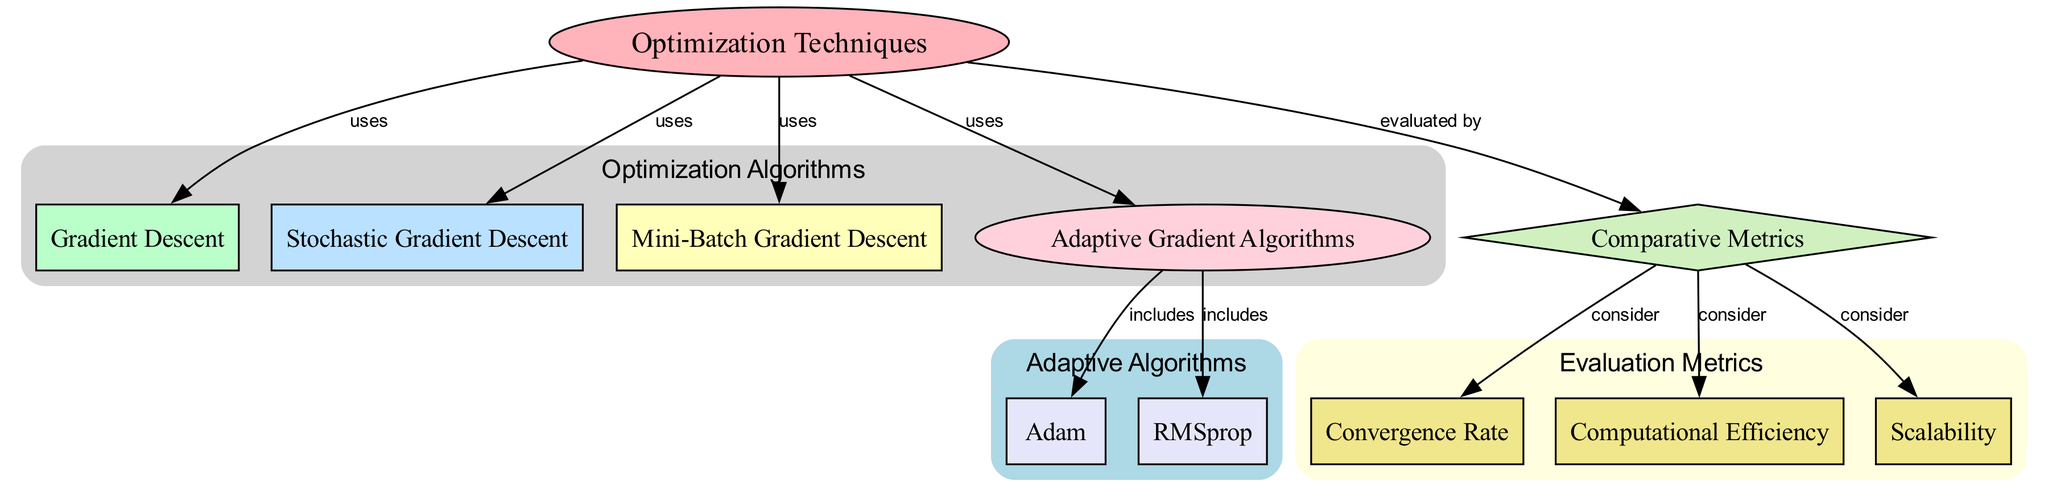What are the primary optimization techniques shown in the diagram? The diagram lists four primary optimization techniques: Gradient Descent, Stochastic Gradient Descent, Mini-Batch Gradient Descent, and Adaptive Gradient Algorithms. Each technique is represented as a node connected to the main node labeled "Optimization Techniques."
Answer: Gradient Descent, Stochastic Gradient Descent, Mini-Batch Gradient Descent, Adaptive Gradient Algorithms How many adaptive algorithms are included in the diagram? There are two adaptive algorithms indicated in the diagram: Adam and RMSprop. These algorithms are connected to the node labeled "Adaptive Gradient Algorithms," which is a subset of the primary optimization techniques.
Answer: 2 What metrics are used for evaluation in the diagram? The diagram highlights three metrics for evaluation: Convergence Rate, Computational Efficiency, and Scalability. Each metric is linked to the node labeled "Comparative Metrics," illustrating the criteria used to evaluate the optimization techniques.
Answer: Convergence Rate, Computational Efficiency, Scalability Which optimization technique is associated with Adam? Adam is connected to the node labeled "Adaptive Gradient Algorithms," which indicates that it is one of the implementations within this category of optimization techniques.
Answer: Adaptive Gradient Algorithms Which evaluation metric would you consider when comparing the performance of the algorithms? The diagram suggests three metrics to consider: Convergence Rate, Computational Efficiency, and Scalability, providing a comprehensive view of how to assess the various optimization techniques.
Answer: Convergence Rate, Computational Efficiency, Scalability How are Stochastic Gradient Descent and Mini-Batch Gradient Descent categorized? Both Stochastic Gradient Descent and Mini-Batch Gradient Descent are categorized under the main node labeled "Optimization Techniques," indicating they are alternative methods for training neural networks that modify the standard Gradient Descent approach.
Answer: Optimization Techniques 